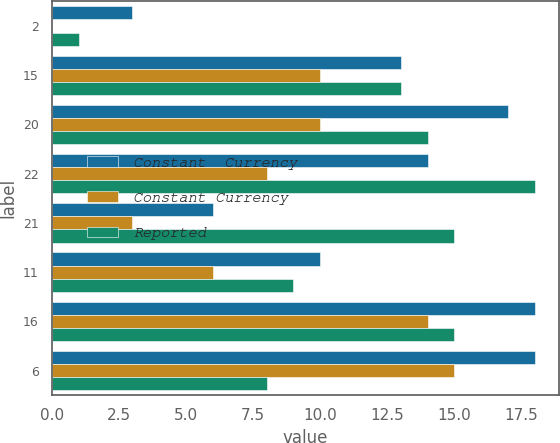Convert chart to OTSL. <chart><loc_0><loc_0><loc_500><loc_500><stacked_bar_chart><ecel><fcel>2<fcel>15<fcel>20<fcel>22<fcel>21<fcel>11<fcel>16<fcel>6<nl><fcel>Constant  Currency<fcel>3<fcel>13<fcel>17<fcel>14<fcel>6<fcel>10<fcel>18<fcel>18<nl><fcel>Constant Currency<fcel>0<fcel>10<fcel>10<fcel>8<fcel>3<fcel>6<fcel>14<fcel>15<nl><fcel>Reported<fcel>1<fcel>13<fcel>14<fcel>18<fcel>15<fcel>9<fcel>15<fcel>8<nl></chart> 